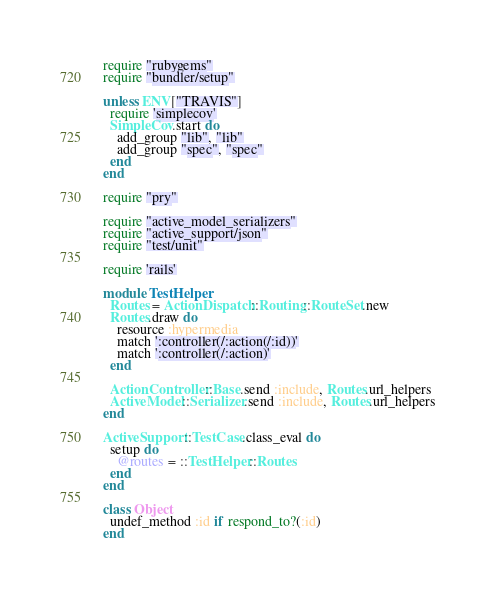Convert code to text. <code><loc_0><loc_0><loc_500><loc_500><_Ruby_>require "rubygems"
require "bundler/setup"

unless ENV["TRAVIS"]
  require 'simplecov'
  SimpleCov.start do
    add_group "lib", "lib"
    add_group "spec", "spec"
  end
end

require "pry"

require "active_model_serializers"
require "active_support/json"
require "test/unit"

require 'rails'

module TestHelper
  Routes = ActionDispatch::Routing::RouteSet.new
  Routes.draw do
    resource :hypermedia
    match ':controller(/:action(/:id))'
    match ':controller(/:action)'
  end

  ActionController::Base.send :include, Routes.url_helpers
  ActiveModel::Serializer.send :include, Routes.url_helpers
end

ActiveSupport::TestCase.class_eval do
  setup do
    @routes = ::TestHelper::Routes
  end
end

class Object
  undef_method :id if respond_to?(:id)
end</code> 